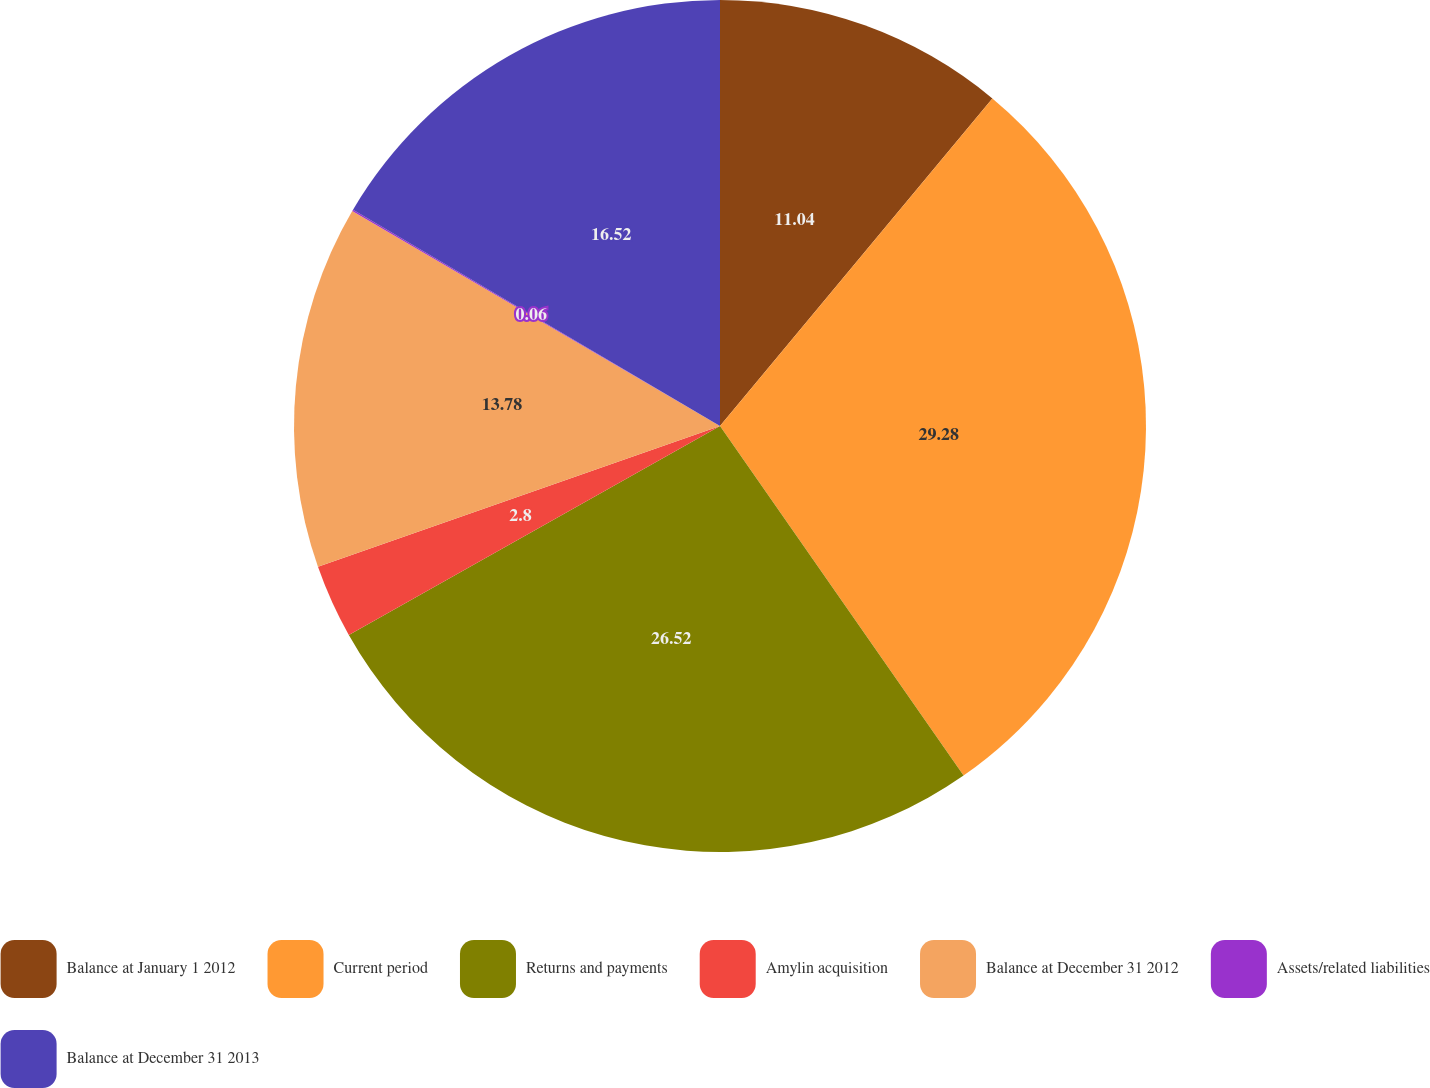<chart> <loc_0><loc_0><loc_500><loc_500><pie_chart><fcel>Balance at January 1 2012<fcel>Current period<fcel>Returns and payments<fcel>Amylin acquisition<fcel>Balance at December 31 2012<fcel>Assets/related liabilities<fcel>Balance at December 31 2013<nl><fcel>11.04%<fcel>29.27%<fcel>26.52%<fcel>2.8%<fcel>13.78%<fcel>0.06%<fcel>16.52%<nl></chart> 